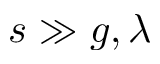Convert formula to latex. <formula><loc_0><loc_0><loc_500><loc_500>s \gg g , \lambda</formula> 